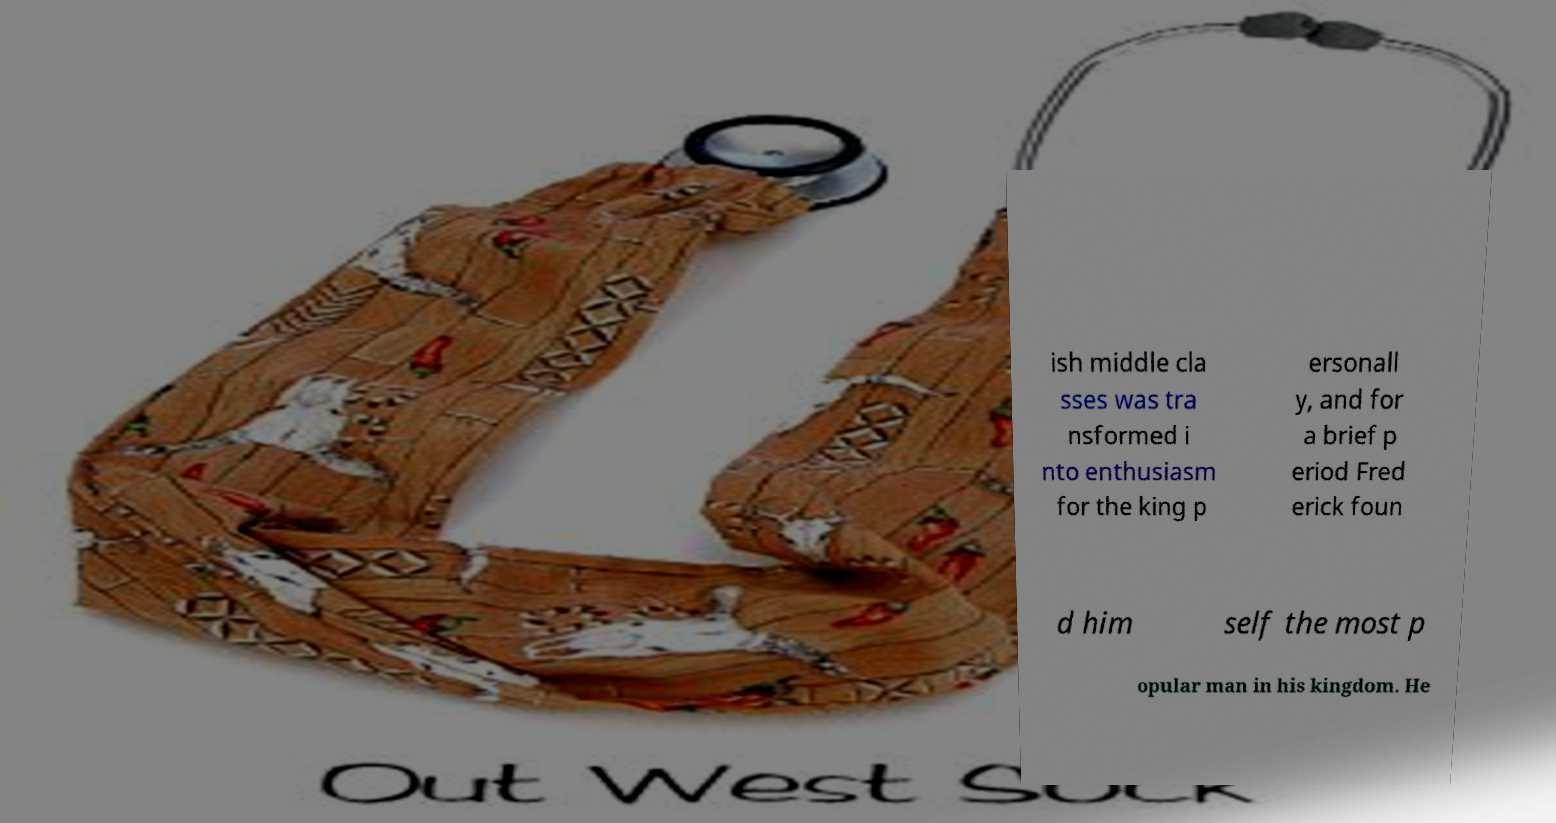Could you assist in decoding the text presented in this image and type it out clearly? ish middle cla sses was tra nsformed i nto enthusiasm for the king p ersonall y, and for a brief p eriod Fred erick foun d him self the most p opular man in his kingdom. He 